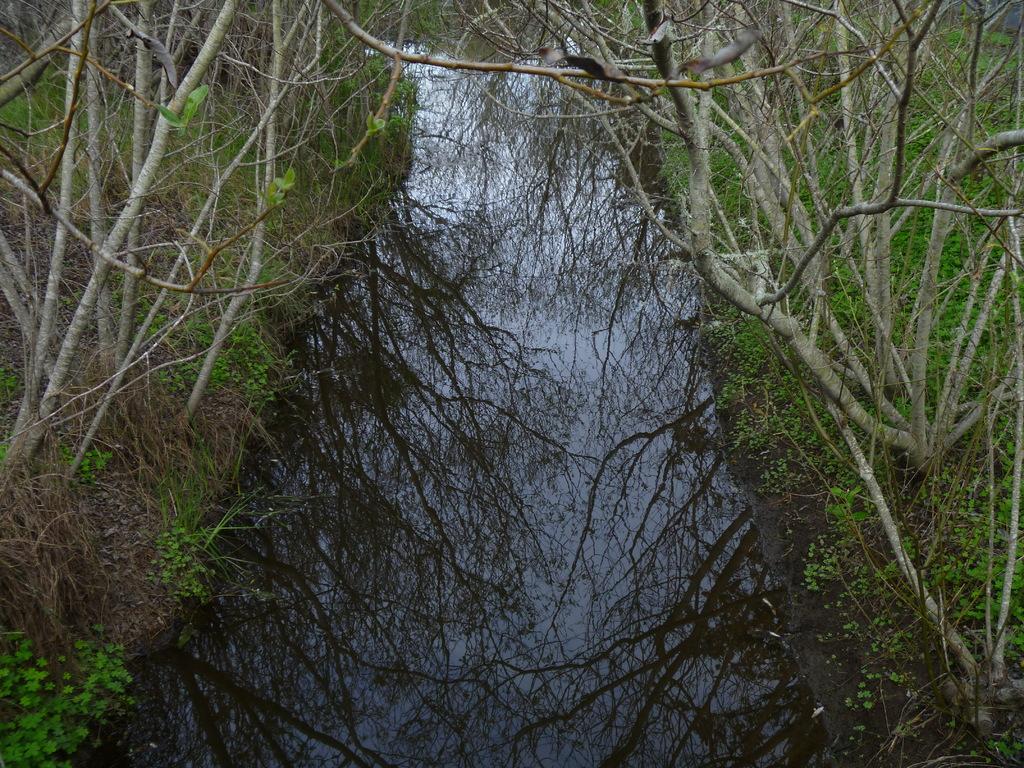How would you summarize this image in a sentence or two? In the middle this is water, there are trees. 